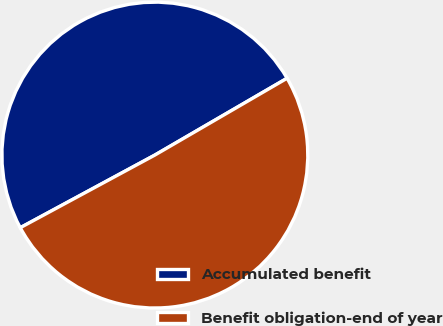<chart> <loc_0><loc_0><loc_500><loc_500><pie_chart><fcel>Accumulated benefit<fcel>Benefit obligation-end of year<nl><fcel>49.5%<fcel>50.5%<nl></chart> 